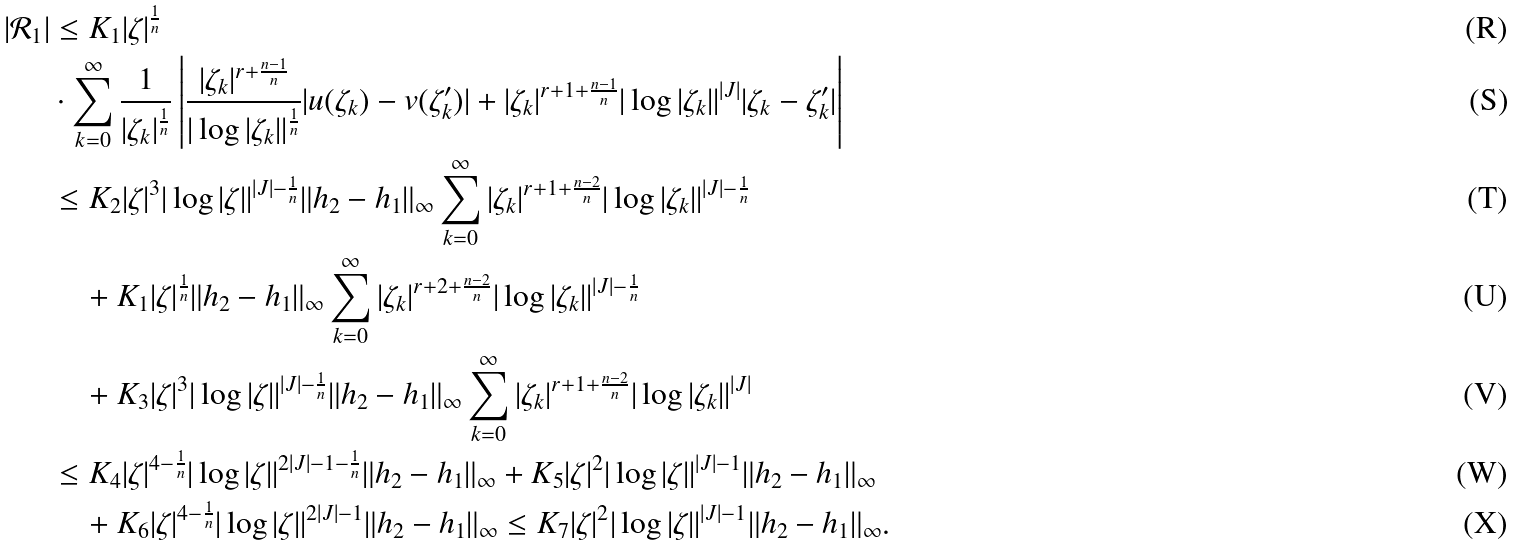Convert formula to latex. <formula><loc_0><loc_0><loc_500><loc_500>| \mathcal { R } _ { 1 } | & \leq K _ { 1 } | \zeta | ^ { \frac { 1 } { n } } \\ & \cdot \sum _ { k = 0 } ^ { \infty } \frac { 1 } { | \zeta _ { k } | ^ { \frac { 1 } { n } } } \left | \frac { | \zeta _ { k } | ^ { r + \frac { n - 1 } { n } } } { | \log | \zeta _ { k } | | ^ { \frac { 1 } { n } } } | u ( \zeta _ { k } ) - v ( \zeta ^ { \prime } _ { k } ) | + | \zeta _ { k } | ^ { r + 1 + \frac { n - 1 } { n } } | \log | \zeta _ { k } | | ^ { | J | } | \zeta _ { k } - \zeta ^ { \prime } _ { k } | \right | \\ & \leq K _ { 2 } | \zeta | ^ { 3 } | \log | \zeta | | ^ { | J | - \frac { 1 } { n } } \| h _ { 2 } - h _ { 1 } \| _ { \infty } \sum _ { k = 0 } ^ { \infty } | \zeta _ { k } | ^ { r + 1 + \frac { n - 2 } { n } } | \log | \zeta _ { k } | | ^ { | J | - \frac { 1 } { n } } \\ & \quad + K _ { 1 } | \zeta | ^ { \frac { 1 } { n } } \| h _ { 2 } - h _ { 1 } \| _ { \infty } \sum _ { k = 0 } ^ { \infty } | \zeta _ { k } | ^ { r + 2 + \frac { n - 2 } { n } } | \log | \zeta _ { k } | | ^ { | J | - \frac { 1 } { n } } \\ & \quad + K _ { 3 } | \zeta | ^ { 3 } | \log | \zeta | | ^ { | J | - \frac { 1 } { n } } \| h _ { 2 } - h _ { 1 } \| _ { \infty } \sum _ { k = 0 } ^ { \infty } | \zeta _ { k } | ^ { r + 1 + \frac { n - 2 } { n } } | \log | \zeta _ { k } | | ^ { | J | } \\ & \leq K _ { 4 } | \zeta | ^ { 4 - \frac { 1 } { n } } | \log | \zeta | | ^ { 2 | J | - 1 - \frac { 1 } { n } } \| h _ { 2 } - h _ { 1 } \| _ { \infty } + K _ { 5 } | \zeta | ^ { 2 } | \log | \zeta | | ^ { | J | - 1 } \| h _ { 2 } - h _ { 1 } \| _ { \infty } \\ & \quad + K _ { 6 } | \zeta | ^ { 4 - \frac { 1 } { n } } | \log | \zeta | | ^ { 2 | J | - 1 } \| h _ { 2 } - h _ { 1 } \| _ { \infty } \leq K _ { 7 } | \zeta | ^ { 2 } | \log | \zeta | | ^ { | J | - 1 } \| h _ { 2 } - h _ { 1 } \| _ { \infty } .</formula> 